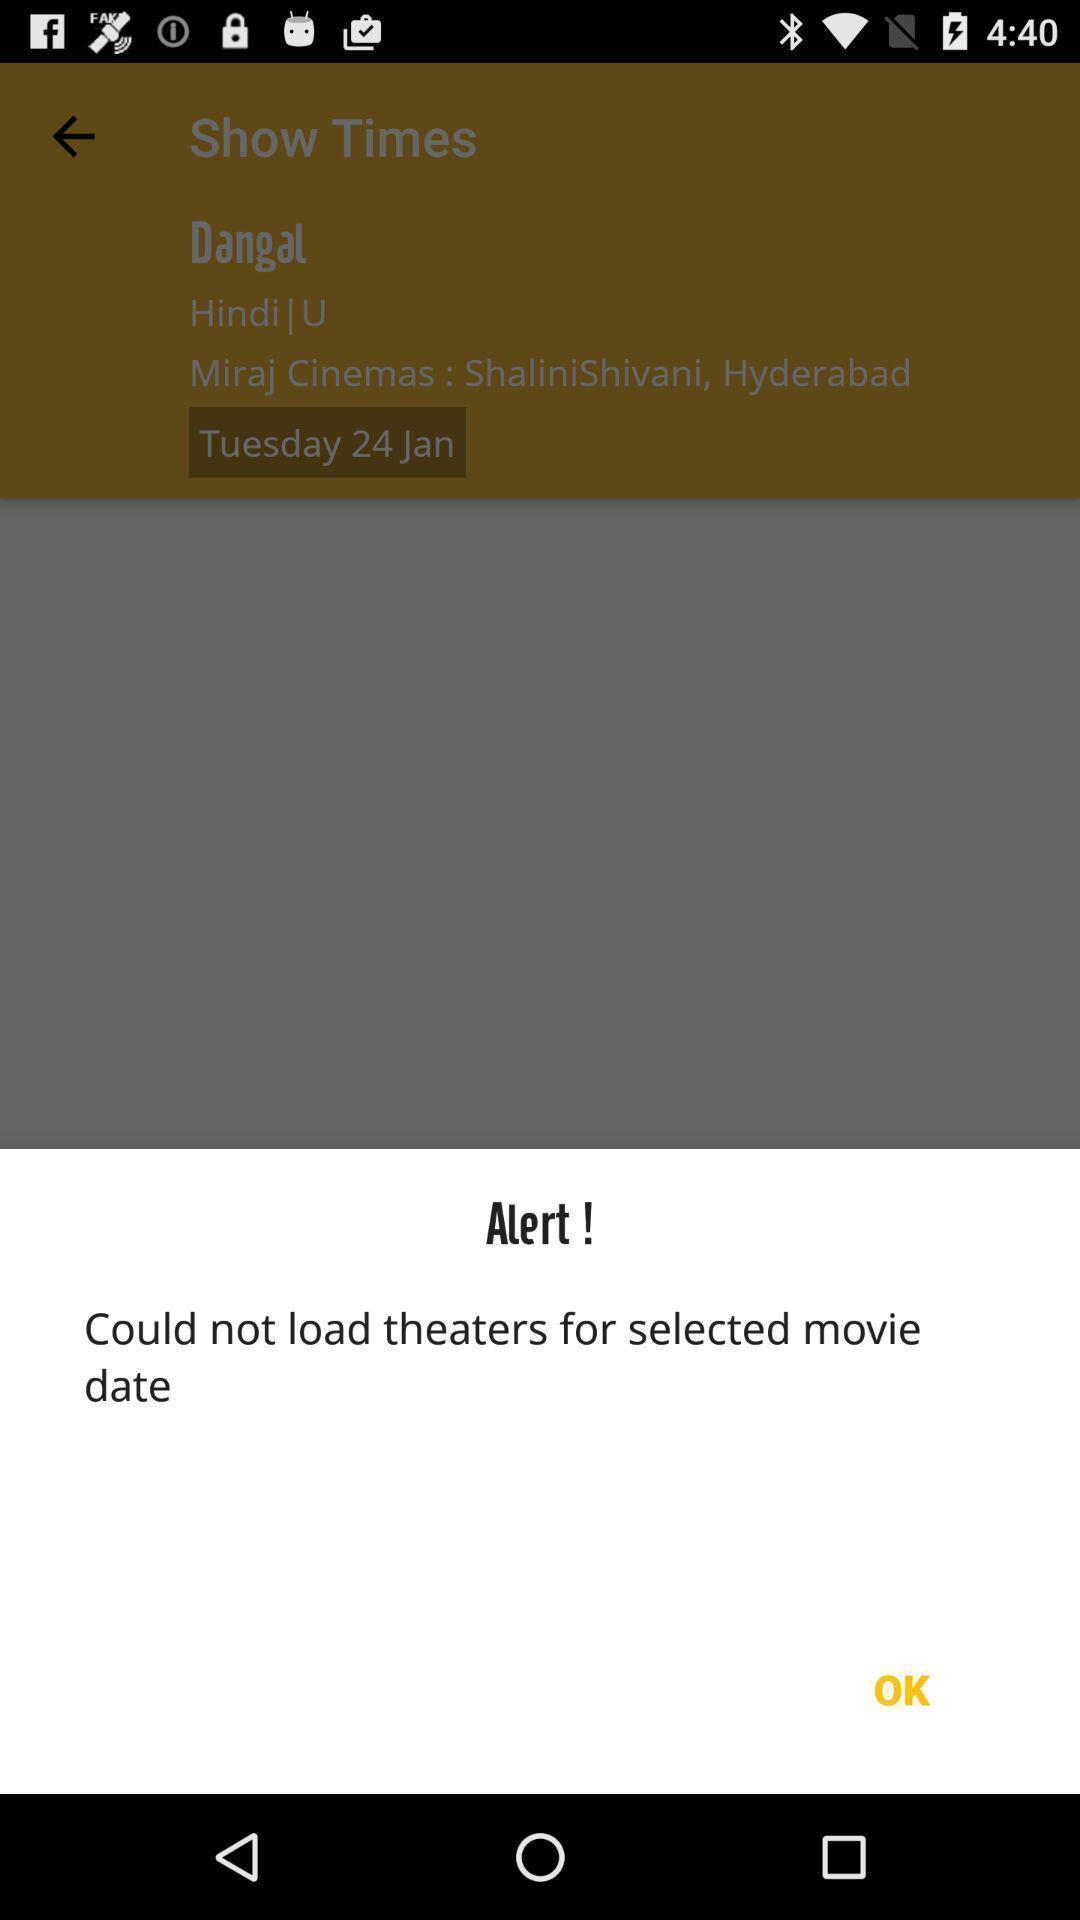Describe the key features of this screenshot. Pop-up showing an alert message. 